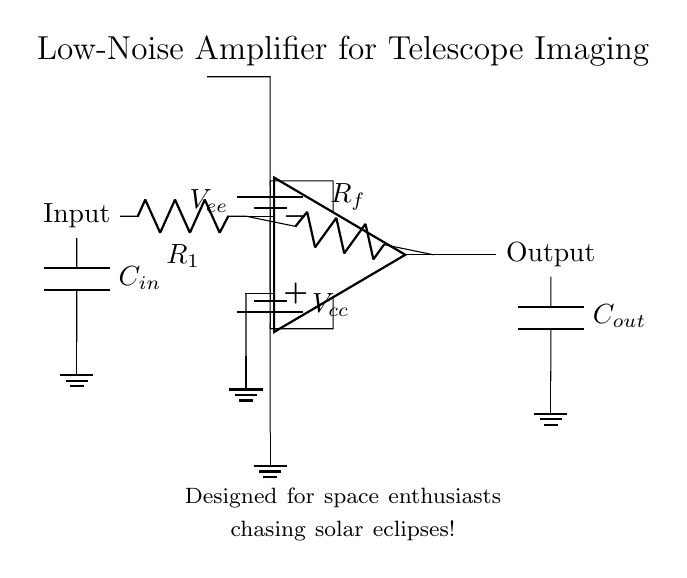What type of amplifier is shown in the circuit? The circuit diagram displays a low-noise amplifier, as indicated in the title of the diagram that specifies its purpose for telescope imaging.
Answer: low-noise amplifier What is the function of the resistor labeled R1? R1 is typically used to set the input impedance of the amplifier. In this configuration, it helps determine how the circuit interacts with the input signal for optimal performance.
Answer: input impedance How many capacitors are present in the circuit? The circuit contains two capacitors labeled as C_in and C_out, each connecting to the input and output of the amplifier, respectively.
Answer: two What are the voltage supplies used in this amplifier? The amplifying circuit employs V_cc for the positive supply and V_ee for the negative supply, which are common in operational amplifier configurations.
Answer: V_cc, V_ee What is the purpose of the feedback resistor R_f in the circuit? R_f provides negative feedback that stabilizes the gain of the amplifier. It allows for controlling the gain by setting how much of the output voltage is fed back to the input.
Answer: negative feedback If the amplifier were to produce a gain of 10, what would R_f typically be in relation to R1? To achieve a gain of 10, R_f would need to be 9 times R1. This follows the common feedback formula for amplifiers where gain is determined by the ratio of R_f to R1.
Answer: R_f = 9 * R1 